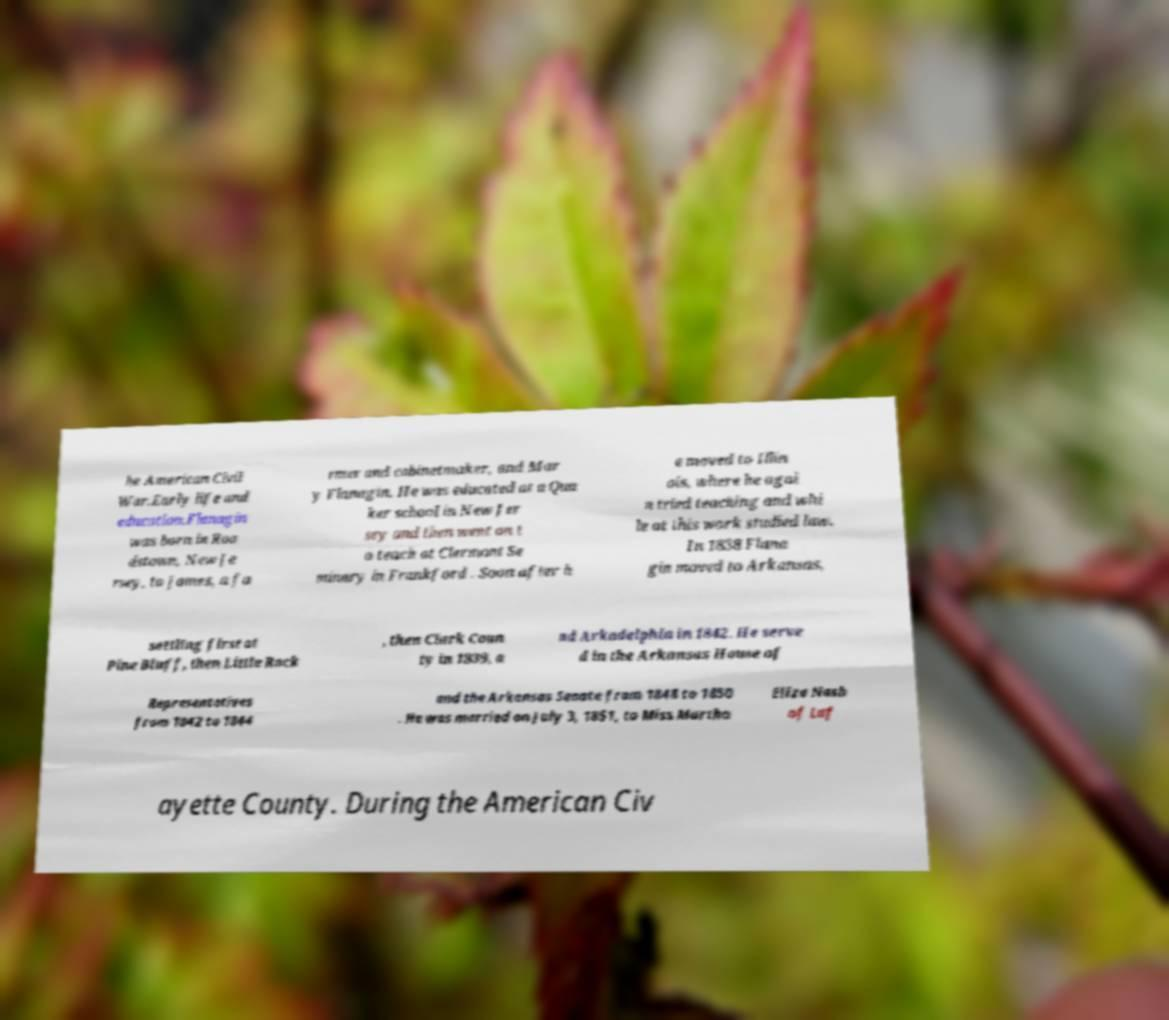Can you read and provide the text displayed in the image?This photo seems to have some interesting text. Can you extract and type it out for me? he American Civil War.Early life and education.Flanagin was born in Roa dstown, New Je rsey, to James, a fa rmer and cabinetmaker, and Mar y Flanagin. He was educated at a Qua ker school in New Jer sey and then went on t o teach at Clermont Se minary in Frankford . Soon after h e moved to Illin ois, where he agai n tried teaching and whi le at this work studied law. In 1838 Flana gin moved to Arkansas, settling first at Pine Bluff, then Little Rock , then Clark Coun ty in 1839, a nd Arkadelphia in 1842. He serve d in the Arkansas House of Representatives from 1842 to 1844 and the Arkansas Senate from 1848 to 1850 . He was married on July 3, 1851, to Miss Martha Eliza Nash of Laf ayette County. During the American Civ 